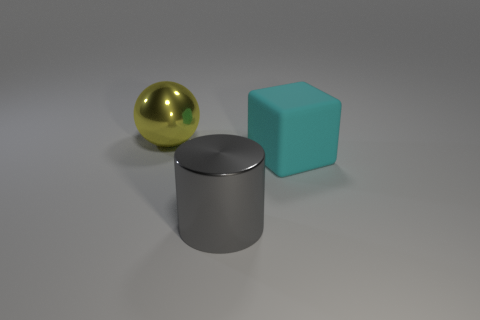Is there any other thing that has the same shape as the large yellow metal object?
Give a very brief answer. No. What number of large cyan things are made of the same material as the sphere?
Make the answer very short. 0. Is there a large gray metallic cylinder?
Keep it short and to the point. Yes. How many large metallic balls are the same color as the metal cylinder?
Provide a succinct answer. 0. Are the yellow object and the large object that is in front of the cyan thing made of the same material?
Ensure brevity in your answer.  Yes. Are there more large metal objects to the left of the big gray shiny cylinder than purple metallic things?
Give a very brief answer. Yes. Is there any other thing that has the same size as the cyan block?
Provide a short and direct response. Yes. Are there an equal number of large objects that are in front of the large gray metal cylinder and large cyan objects that are behind the large ball?
Your answer should be compact. Yes. What is the large object that is on the left side of the gray cylinder made of?
Keep it short and to the point. Metal. How many things are shiny things that are in front of the cyan matte block or big brown blocks?
Your answer should be compact. 1. 